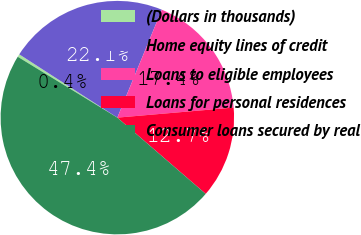<chart> <loc_0><loc_0><loc_500><loc_500><pie_chart><fcel>(Dollars in thousands)<fcel>Home equity lines of credit<fcel>Loans to eligible employees<fcel>Loans for personal residences<fcel>Consumer loans secured by real<nl><fcel>0.39%<fcel>22.1%<fcel>17.4%<fcel>12.7%<fcel>47.39%<nl></chart> 